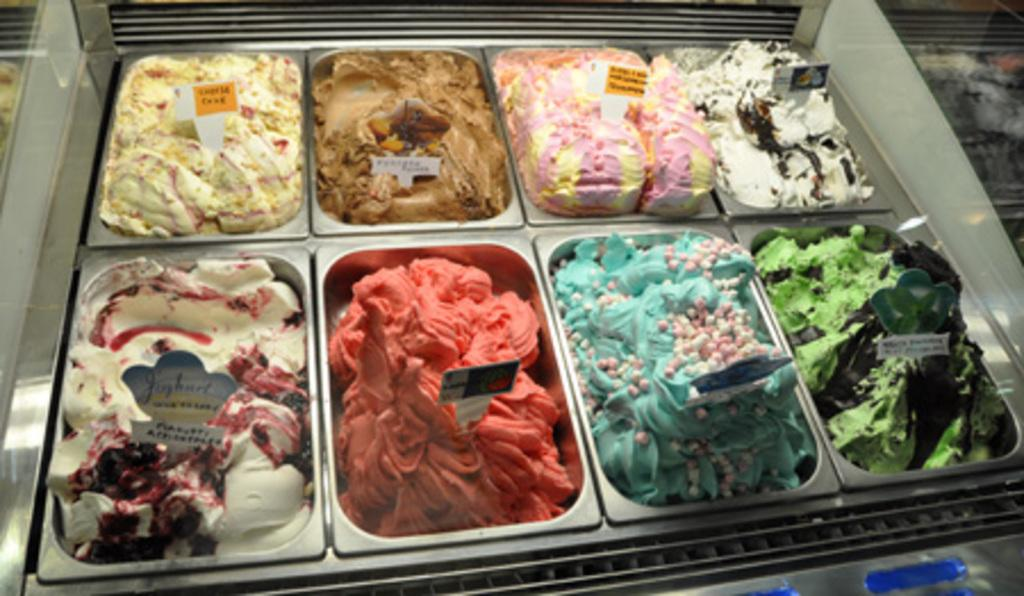What types of ice creams can be seen in the image? There are different flavors of ice creams in the image. How are the ice creams arranged in the image? The ice creams are in trays in the image. How can one identify the flavor of each ice cream? There is a name board for each ice cream flavor in the image. What type of act do the men perform in the image? There are no men or acts present in the image; it features different flavors of ice creams in trays with name boards for each flavor. 